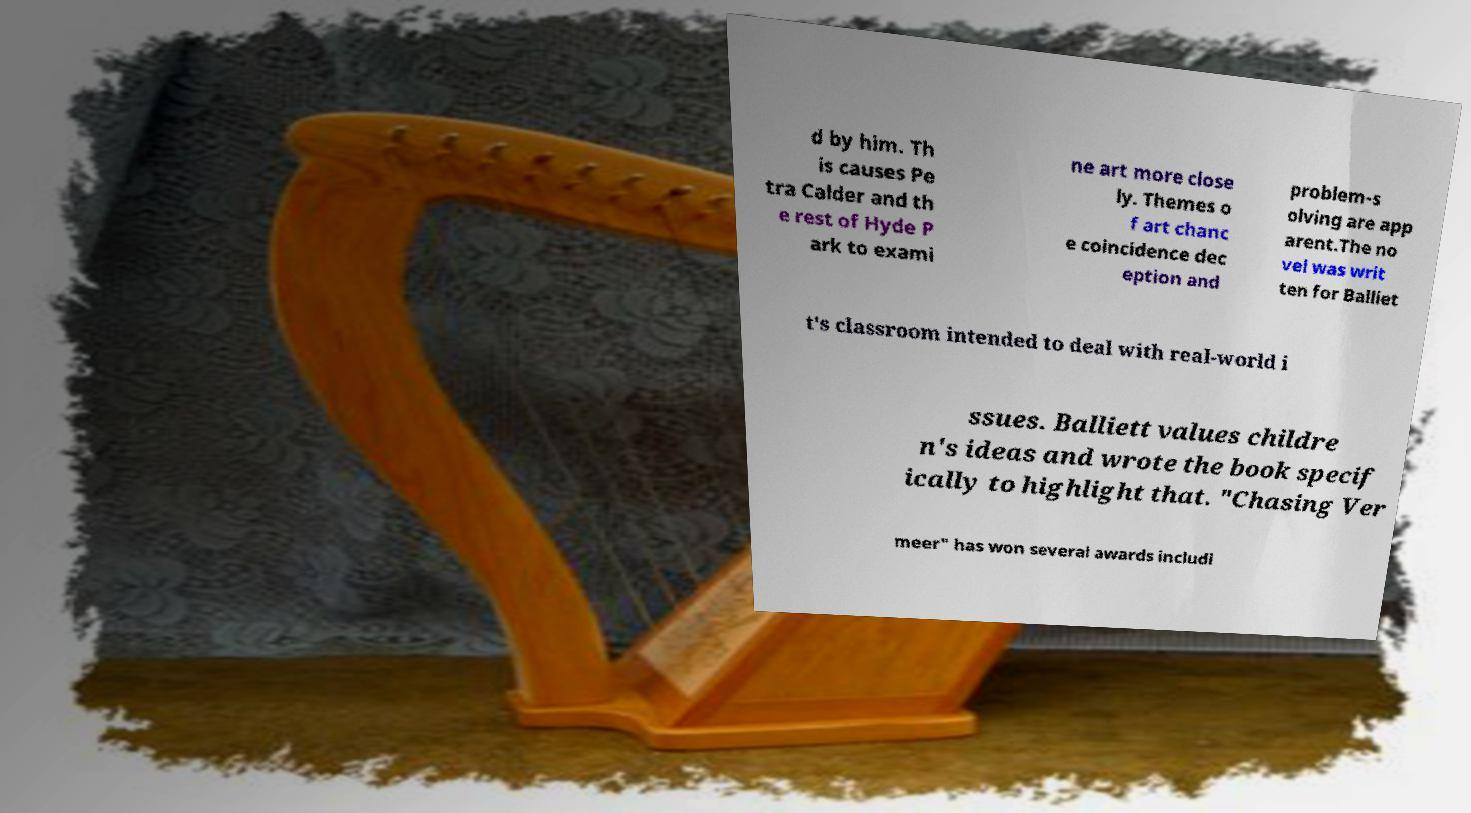Can you read and provide the text displayed in the image?This photo seems to have some interesting text. Can you extract and type it out for me? d by him. Th is causes Pe tra Calder and th e rest of Hyde P ark to exami ne art more close ly. Themes o f art chanc e coincidence dec eption and problem-s olving are app arent.The no vel was writ ten for Balliet t's classroom intended to deal with real-world i ssues. Balliett values childre n's ideas and wrote the book specif ically to highlight that. "Chasing Ver meer" has won several awards includi 